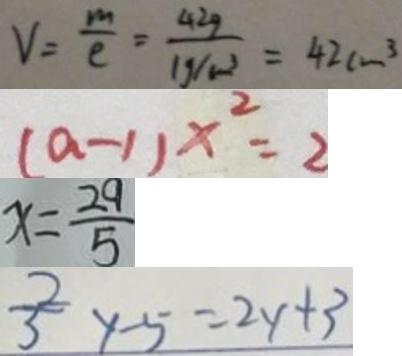Convert formula to latex. <formula><loc_0><loc_0><loc_500><loc_500>V = \frac { m } { c } = \frac { 4 2 g } { 1 g / c m ^ { 3 } } = 4 2 c m ^ { 3 } 
 ( a - 1 ) x ^ { 2 } = 2 
 x = \frac { 2 9 } { 5 } 
 \frac { 2 } { 3 } y - 5 = 2 y + 3</formula> 